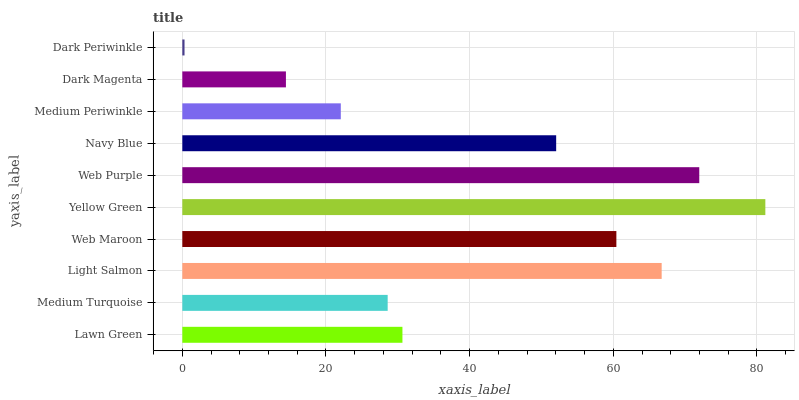Is Dark Periwinkle the minimum?
Answer yes or no. Yes. Is Yellow Green the maximum?
Answer yes or no. Yes. Is Medium Turquoise the minimum?
Answer yes or no. No. Is Medium Turquoise the maximum?
Answer yes or no. No. Is Lawn Green greater than Medium Turquoise?
Answer yes or no. Yes. Is Medium Turquoise less than Lawn Green?
Answer yes or no. Yes. Is Medium Turquoise greater than Lawn Green?
Answer yes or no. No. Is Lawn Green less than Medium Turquoise?
Answer yes or no. No. Is Navy Blue the high median?
Answer yes or no. Yes. Is Lawn Green the low median?
Answer yes or no. Yes. Is Dark Periwinkle the high median?
Answer yes or no. No. Is Web Purple the low median?
Answer yes or no. No. 